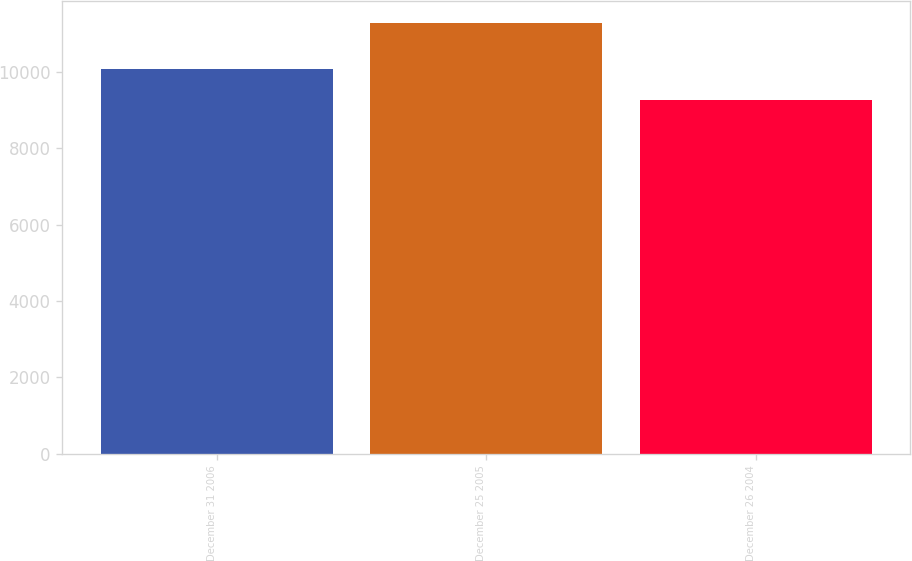Convert chart to OTSL. <chart><loc_0><loc_0><loc_500><loc_500><bar_chart><fcel>December 31 2006<fcel>December 25 2005<fcel>December 26 2004<nl><fcel>10090<fcel>11296<fcel>9273<nl></chart> 